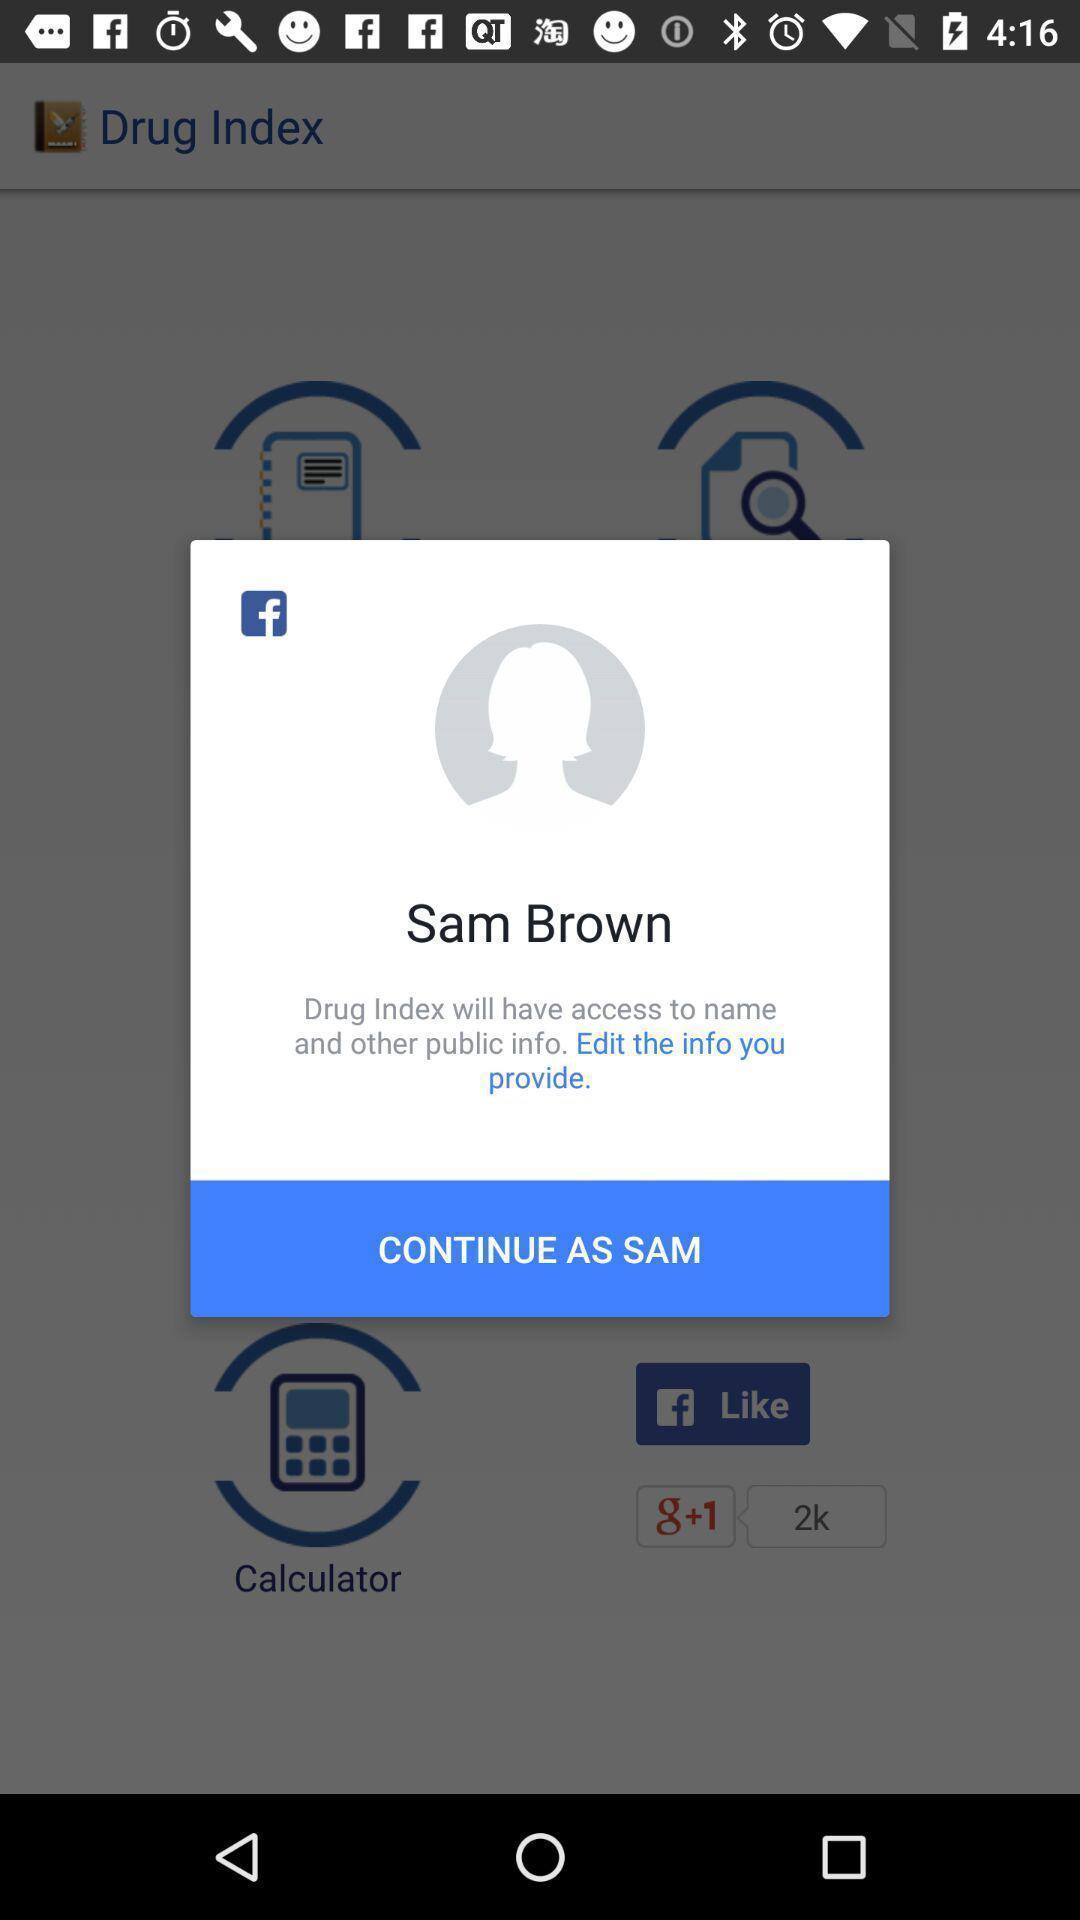Give me a narrative description of this picture. Pop up showing to continue in measuring app. 